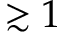<formula> <loc_0><loc_0><loc_500><loc_500>\gtrsim 1</formula> 